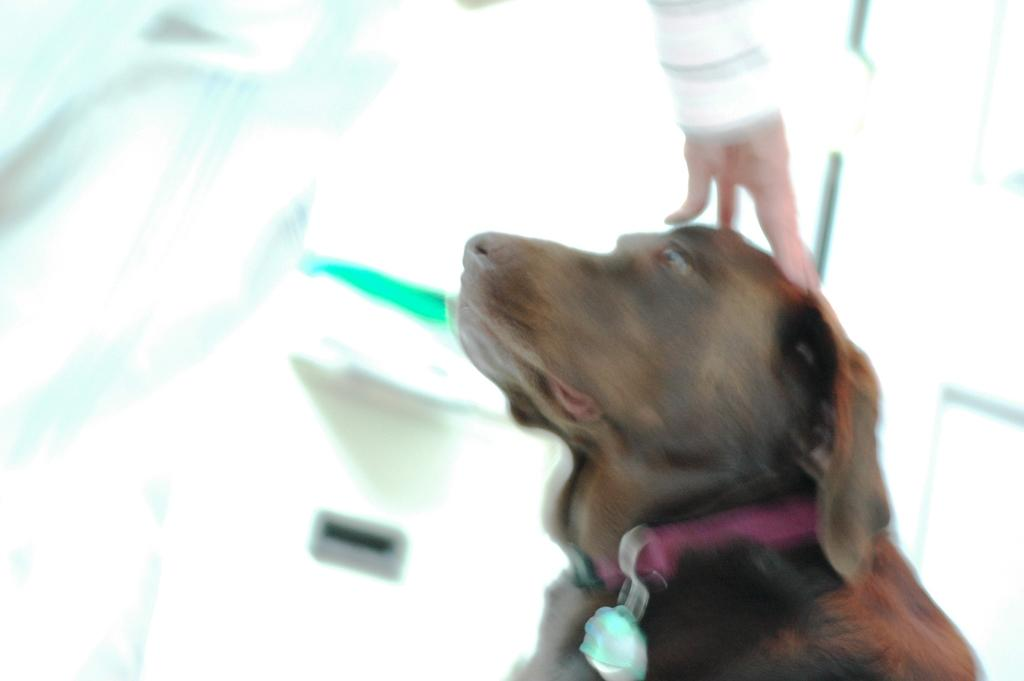What part of a person is visible in the image? There is a person's hand in the image. What is the hand doing in the image? The hand is on the head of a dog. Can you describe the background of the image? The background of the image is blurred. What type of pancake is being served on the plate in the image? There is no plate or pancake present in the image; it only features a person's hand on a dog's head. 